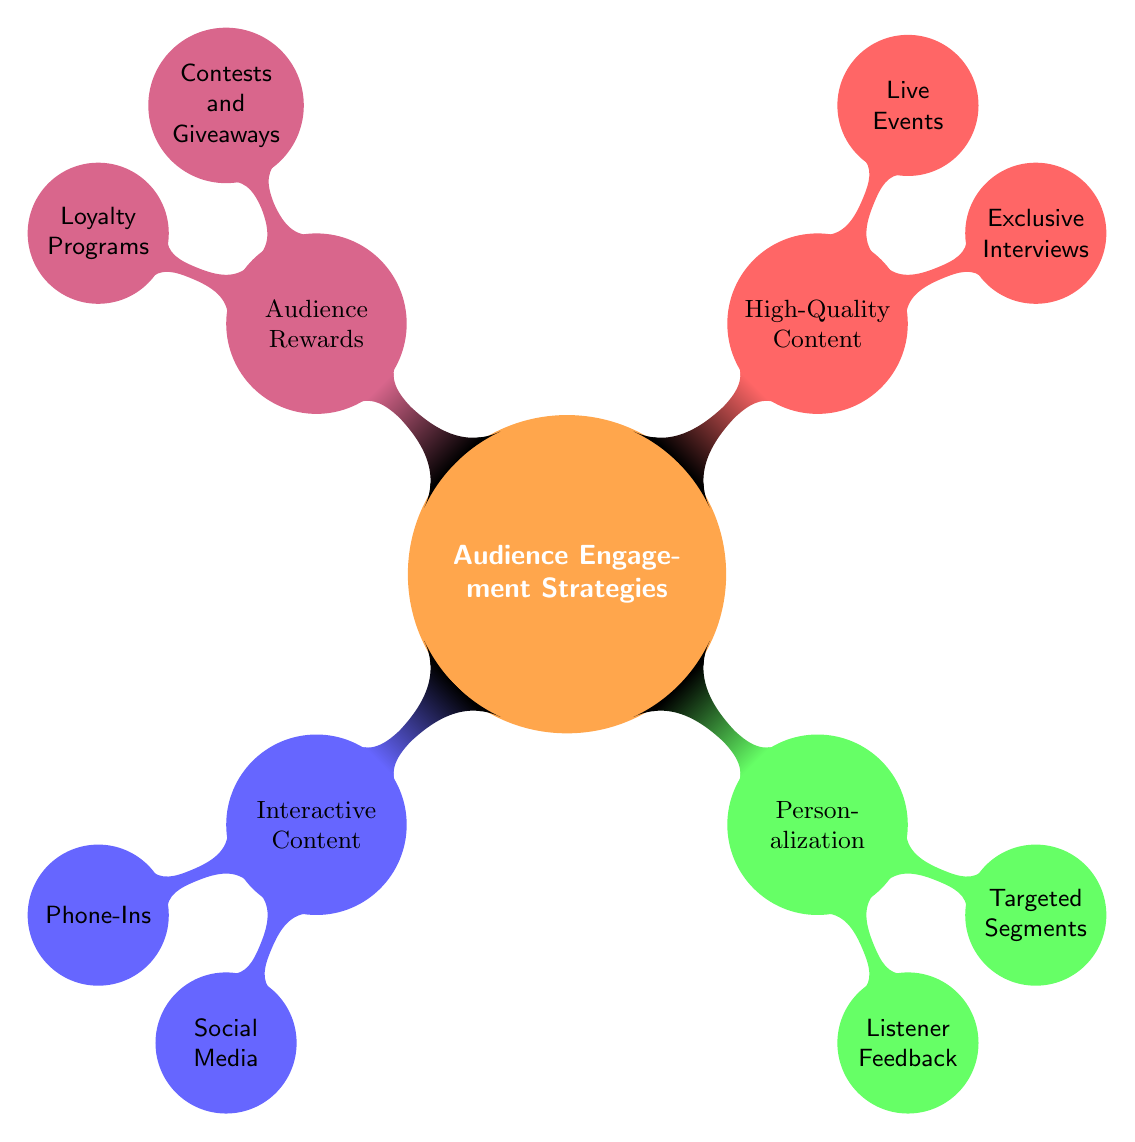What is the main topic of the mind map? The central node of the mind map is labeled "Audience Engagement Strategies," indicating that this is the main topic being explored.
Answer: Audience Engagement Strategies How many main categories are there in the mind map? There are four main categories branching out from the central node: Interactive Content, Personalization, High-Quality Content, and Audience Rewards. Counting these categories gives a total of four.
Answer: 4 What type of engagement strategy involves Listener Feedback? Listener Feedback is categorized under Personalization, which focuses on strategies tailored to individual preferences and demographics.
Answer: Personalization Which category includes Live Events? Live Events are part of the High-Quality Content category, which emphasizes producing valuable and engaging content for the audience.
Answer: High-Quality Content How many sub-nodes does the Audience Rewards category have? Audience Rewards includes two sub-nodes: Contests and Giveaways, and Loyalty Programs. Counting these gives a total of two sub-nodes.
Answer: 2 Which engagement strategy utilizes social media platforms? Social Media is a sub-node under the Interactive Content category, highlighting the use of these platforms for real-time audience interaction.
Answer: Interactive Content Which is a strategy that incentivizes participation? Contests and Giveaways are designed to incentivize audience participation, making them a key feature of the Audience Rewards category.
Answer: Contests and Giveaways What do Exclusive Interviews belong to? Exclusive Interviews are part of the High-Quality Content category, focusing on delivering unique and informative material to listeners.
Answer: High-Quality Content Which two categories have strategies focused on listener interaction? The categories Interactive Content and Audience Rewards both focus on strategies aimed at engaging listeners directly and enhancing their experience.
Answer: Interactive Content and Audience Rewards 